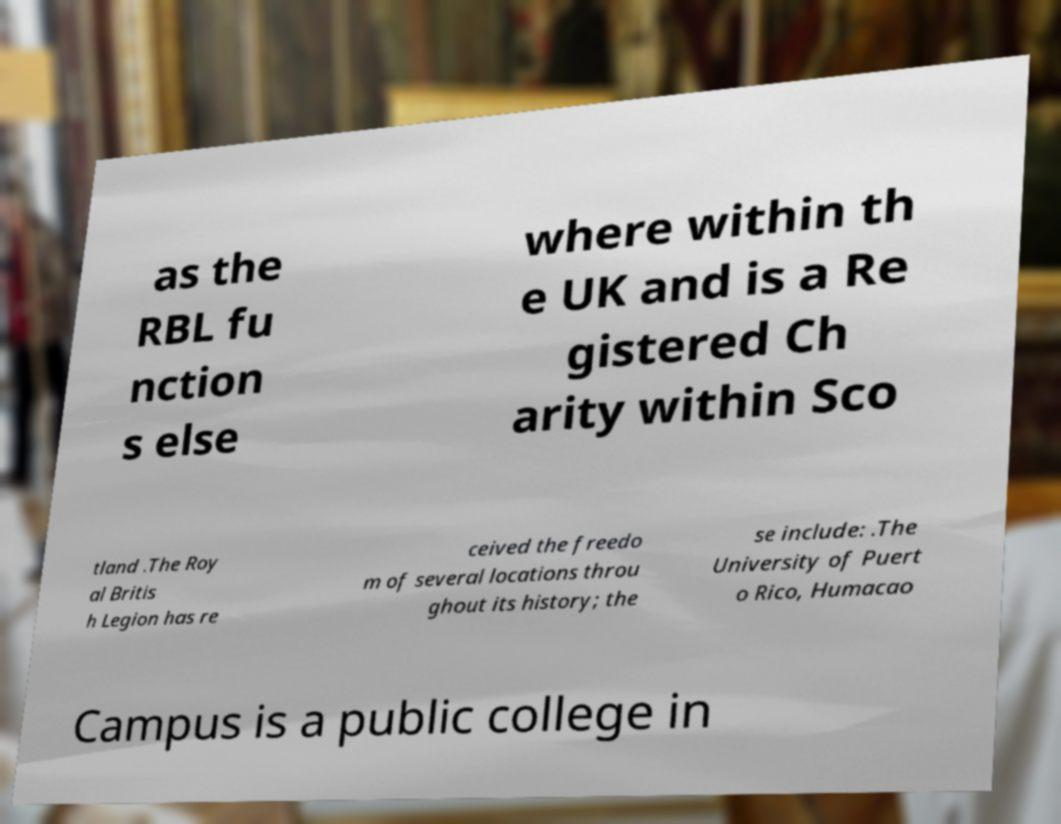Can you accurately transcribe the text from the provided image for me? as the RBL fu nction s else where within th e UK and is a Re gistered Ch arity within Sco tland .The Roy al Britis h Legion has re ceived the freedo m of several locations throu ghout its history; the se include: .The University of Puert o Rico, Humacao Campus is a public college in 